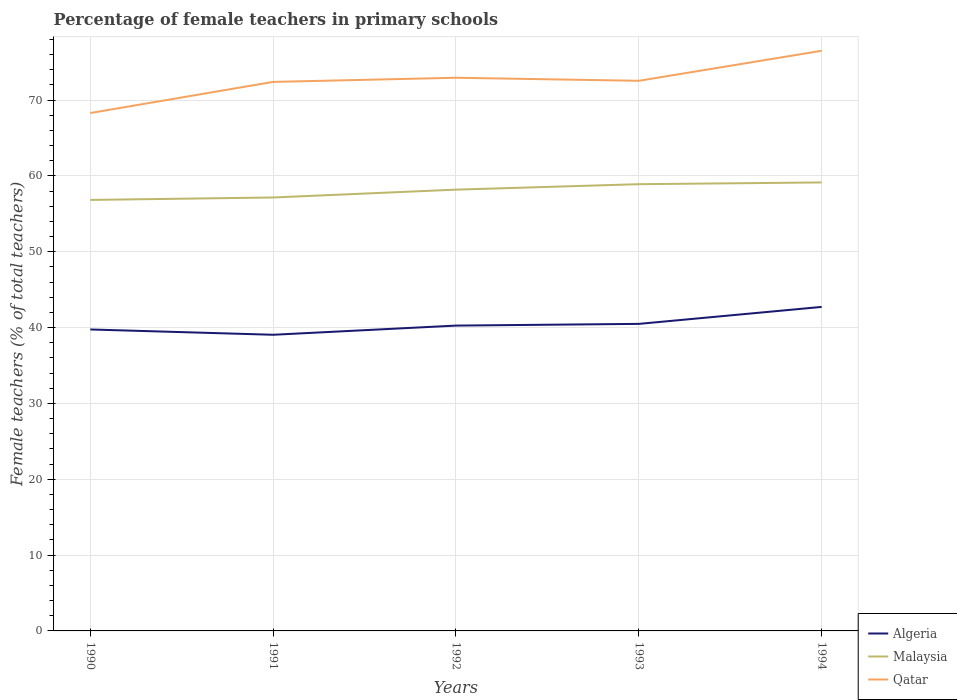Is the number of lines equal to the number of legend labels?
Your answer should be very brief. Yes. Across all years, what is the maximum percentage of female teachers in Malaysia?
Ensure brevity in your answer.  56.84. What is the total percentage of female teachers in Qatar in the graph?
Offer a very short reply. -4.1. What is the difference between the highest and the second highest percentage of female teachers in Qatar?
Offer a very short reply. 8.21. What is the difference between the highest and the lowest percentage of female teachers in Malaysia?
Give a very brief answer. 3. How many lines are there?
Your answer should be very brief. 3. What is the difference between two consecutive major ticks on the Y-axis?
Make the answer very short. 10. Does the graph contain grids?
Keep it short and to the point. Yes. Where does the legend appear in the graph?
Ensure brevity in your answer.  Bottom right. What is the title of the graph?
Provide a short and direct response. Percentage of female teachers in primary schools. Does "Finland" appear as one of the legend labels in the graph?
Ensure brevity in your answer.  No. What is the label or title of the Y-axis?
Keep it short and to the point. Female teachers (% of total teachers). What is the Female teachers (% of total teachers) in Algeria in 1990?
Give a very brief answer. 39.75. What is the Female teachers (% of total teachers) of Malaysia in 1990?
Your answer should be compact. 56.84. What is the Female teachers (% of total teachers) of Qatar in 1990?
Offer a terse response. 68.29. What is the Female teachers (% of total teachers) in Algeria in 1991?
Your answer should be very brief. 39.05. What is the Female teachers (% of total teachers) in Malaysia in 1991?
Give a very brief answer. 57.16. What is the Female teachers (% of total teachers) in Qatar in 1991?
Make the answer very short. 72.4. What is the Female teachers (% of total teachers) in Algeria in 1992?
Give a very brief answer. 40.26. What is the Female teachers (% of total teachers) in Malaysia in 1992?
Offer a terse response. 58.19. What is the Female teachers (% of total teachers) of Qatar in 1992?
Give a very brief answer. 72.94. What is the Female teachers (% of total teachers) of Algeria in 1993?
Provide a short and direct response. 40.49. What is the Female teachers (% of total teachers) in Malaysia in 1993?
Ensure brevity in your answer.  58.91. What is the Female teachers (% of total teachers) in Qatar in 1993?
Offer a terse response. 72.54. What is the Female teachers (% of total teachers) in Algeria in 1994?
Provide a succinct answer. 42.73. What is the Female teachers (% of total teachers) of Malaysia in 1994?
Make the answer very short. 59.14. What is the Female teachers (% of total teachers) of Qatar in 1994?
Your response must be concise. 76.5. Across all years, what is the maximum Female teachers (% of total teachers) of Algeria?
Your answer should be compact. 42.73. Across all years, what is the maximum Female teachers (% of total teachers) of Malaysia?
Your response must be concise. 59.14. Across all years, what is the maximum Female teachers (% of total teachers) of Qatar?
Your answer should be compact. 76.5. Across all years, what is the minimum Female teachers (% of total teachers) of Algeria?
Ensure brevity in your answer.  39.05. Across all years, what is the minimum Female teachers (% of total teachers) in Malaysia?
Offer a very short reply. 56.84. Across all years, what is the minimum Female teachers (% of total teachers) in Qatar?
Offer a terse response. 68.29. What is the total Female teachers (% of total teachers) in Algeria in the graph?
Your answer should be compact. 202.28. What is the total Female teachers (% of total teachers) of Malaysia in the graph?
Provide a short and direct response. 290.23. What is the total Female teachers (% of total teachers) in Qatar in the graph?
Offer a very short reply. 362.68. What is the difference between the Female teachers (% of total teachers) of Algeria in 1990 and that in 1991?
Provide a short and direct response. 0.7. What is the difference between the Female teachers (% of total teachers) in Malaysia in 1990 and that in 1991?
Your answer should be very brief. -0.32. What is the difference between the Female teachers (% of total teachers) of Qatar in 1990 and that in 1991?
Your answer should be compact. -4.11. What is the difference between the Female teachers (% of total teachers) of Algeria in 1990 and that in 1992?
Make the answer very short. -0.51. What is the difference between the Female teachers (% of total teachers) of Malaysia in 1990 and that in 1992?
Make the answer very short. -1.35. What is the difference between the Female teachers (% of total teachers) in Qatar in 1990 and that in 1992?
Offer a very short reply. -4.65. What is the difference between the Female teachers (% of total teachers) of Algeria in 1990 and that in 1993?
Offer a very short reply. -0.74. What is the difference between the Female teachers (% of total teachers) of Malaysia in 1990 and that in 1993?
Give a very brief answer. -2.07. What is the difference between the Female teachers (% of total teachers) of Qatar in 1990 and that in 1993?
Ensure brevity in your answer.  -4.25. What is the difference between the Female teachers (% of total teachers) in Algeria in 1990 and that in 1994?
Keep it short and to the point. -2.98. What is the difference between the Female teachers (% of total teachers) in Malaysia in 1990 and that in 1994?
Offer a terse response. -2.3. What is the difference between the Female teachers (% of total teachers) in Qatar in 1990 and that in 1994?
Your answer should be very brief. -8.21. What is the difference between the Female teachers (% of total teachers) in Algeria in 1991 and that in 1992?
Make the answer very short. -1.21. What is the difference between the Female teachers (% of total teachers) in Malaysia in 1991 and that in 1992?
Offer a very short reply. -1.03. What is the difference between the Female teachers (% of total teachers) in Qatar in 1991 and that in 1992?
Provide a short and direct response. -0.55. What is the difference between the Female teachers (% of total teachers) in Algeria in 1991 and that in 1993?
Ensure brevity in your answer.  -1.43. What is the difference between the Female teachers (% of total teachers) in Malaysia in 1991 and that in 1993?
Give a very brief answer. -1.75. What is the difference between the Female teachers (% of total teachers) of Qatar in 1991 and that in 1993?
Keep it short and to the point. -0.15. What is the difference between the Female teachers (% of total teachers) in Algeria in 1991 and that in 1994?
Ensure brevity in your answer.  -3.67. What is the difference between the Female teachers (% of total teachers) in Malaysia in 1991 and that in 1994?
Your response must be concise. -1.98. What is the difference between the Female teachers (% of total teachers) in Qatar in 1991 and that in 1994?
Give a very brief answer. -4.1. What is the difference between the Female teachers (% of total teachers) of Algeria in 1992 and that in 1993?
Ensure brevity in your answer.  -0.23. What is the difference between the Female teachers (% of total teachers) in Malaysia in 1992 and that in 1993?
Provide a succinct answer. -0.72. What is the difference between the Female teachers (% of total teachers) of Qatar in 1992 and that in 1993?
Offer a very short reply. 0.4. What is the difference between the Female teachers (% of total teachers) of Algeria in 1992 and that in 1994?
Ensure brevity in your answer.  -2.46. What is the difference between the Female teachers (% of total teachers) in Malaysia in 1992 and that in 1994?
Provide a succinct answer. -0.95. What is the difference between the Female teachers (% of total teachers) in Qatar in 1992 and that in 1994?
Ensure brevity in your answer.  -3.56. What is the difference between the Female teachers (% of total teachers) in Algeria in 1993 and that in 1994?
Offer a very short reply. -2.24. What is the difference between the Female teachers (% of total teachers) in Malaysia in 1993 and that in 1994?
Offer a very short reply. -0.23. What is the difference between the Female teachers (% of total teachers) of Qatar in 1993 and that in 1994?
Provide a short and direct response. -3.96. What is the difference between the Female teachers (% of total teachers) of Algeria in 1990 and the Female teachers (% of total teachers) of Malaysia in 1991?
Give a very brief answer. -17.41. What is the difference between the Female teachers (% of total teachers) of Algeria in 1990 and the Female teachers (% of total teachers) of Qatar in 1991?
Ensure brevity in your answer.  -32.65. What is the difference between the Female teachers (% of total teachers) in Malaysia in 1990 and the Female teachers (% of total teachers) in Qatar in 1991?
Provide a short and direct response. -15.56. What is the difference between the Female teachers (% of total teachers) of Algeria in 1990 and the Female teachers (% of total teachers) of Malaysia in 1992?
Offer a very short reply. -18.44. What is the difference between the Female teachers (% of total teachers) in Algeria in 1990 and the Female teachers (% of total teachers) in Qatar in 1992?
Offer a terse response. -33.19. What is the difference between the Female teachers (% of total teachers) in Malaysia in 1990 and the Female teachers (% of total teachers) in Qatar in 1992?
Your answer should be compact. -16.11. What is the difference between the Female teachers (% of total teachers) in Algeria in 1990 and the Female teachers (% of total teachers) in Malaysia in 1993?
Give a very brief answer. -19.16. What is the difference between the Female teachers (% of total teachers) in Algeria in 1990 and the Female teachers (% of total teachers) in Qatar in 1993?
Your answer should be compact. -32.79. What is the difference between the Female teachers (% of total teachers) in Malaysia in 1990 and the Female teachers (% of total teachers) in Qatar in 1993?
Provide a short and direct response. -15.71. What is the difference between the Female teachers (% of total teachers) in Algeria in 1990 and the Female teachers (% of total teachers) in Malaysia in 1994?
Your answer should be very brief. -19.39. What is the difference between the Female teachers (% of total teachers) of Algeria in 1990 and the Female teachers (% of total teachers) of Qatar in 1994?
Offer a terse response. -36.75. What is the difference between the Female teachers (% of total teachers) in Malaysia in 1990 and the Female teachers (% of total teachers) in Qatar in 1994?
Ensure brevity in your answer.  -19.67. What is the difference between the Female teachers (% of total teachers) in Algeria in 1991 and the Female teachers (% of total teachers) in Malaysia in 1992?
Your answer should be compact. -19.14. What is the difference between the Female teachers (% of total teachers) of Algeria in 1991 and the Female teachers (% of total teachers) of Qatar in 1992?
Provide a short and direct response. -33.89. What is the difference between the Female teachers (% of total teachers) of Malaysia in 1991 and the Female teachers (% of total teachers) of Qatar in 1992?
Offer a terse response. -15.79. What is the difference between the Female teachers (% of total teachers) in Algeria in 1991 and the Female teachers (% of total teachers) in Malaysia in 1993?
Give a very brief answer. -19.86. What is the difference between the Female teachers (% of total teachers) in Algeria in 1991 and the Female teachers (% of total teachers) in Qatar in 1993?
Provide a short and direct response. -33.49. What is the difference between the Female teachers (% of total teachers) of Malaysia in 1991 and the Female teachers (% of total teachers) of Qatar in 1993?
Offer a terse response. -15.39. What is the difference between the Female teachers (% of total teachers) in Algeria in 1991 and the Female teachers (% of total teachers) in Malaysia in 1994?
Make the answer very short. -20.09. What is the difference between the Female teachers (% of total teachers) in Algeria in 1991 and the Female teachers (% of total teachers) in Qatar in 1994?
Provide a short and direct response. -37.45. What is the difference between the Female teachers (% of total teachers) of Malaysia in 1991 and the Female teachers (% of total teachers) of Qatar in 1994?
Offer a very short reply. -19.35. What is the difference between the Female teachers (% of total teachers) in Algeria in 1992 and the Female teachers (% of total teachers) in Malaysia in 1993?
Provide a succinct answer. -18.65. What is the difference between the Female teachers (% of total teachers) in Algeria in 1992 and the Female teachers (% of total teachers) in Qatar in 1993?
Provide a succinct answer. -32.28. What is the difference between the Female teachers (% of total teachers) of Malaysia in 1992 and the Female teachers (% of total teachers) of Qatar in 1993?
Keep it short and to the point. -14.35. What is the difference between the Female teachers (% of total teachers) of Algeria in 1992 and the Female teachers (% of total teachers) of Malaysia in 1994?
Offer a very short reply. -18.88. What is the difference between the Female teachers (% of total teachers) of Algeria in 1992 and the Female teachers (% of total teachers) of Qatar in 1994?
Your response must be concise. -36.24. What is the difference between the Female teachers (% of total teachers) of Malaysia in 1992 and the Female teachers (% of total teachers) of Qatar in 1994?
Make the answer very short. -18.31. What is the difference between the Female teachers (% of total teachers) of Algeria in 1993 and the Female teachers (% of total teachers) of Malaysia in 1994?
Your response must be concise. -18.65. What is the difference between the Female teachers (% of total teachers) of Algeria in 1993 and the Female teachers (% of total teachers) of Qatar in 1994?
Offer a terse response. -36.01. What is the difference between the Female teachers (% of total teachers) of Malaysia in 1993 and the Female teachers (% of total teachers) of Qatar in 1994?
Keep it short and to the point. -17.59. What is the average Female teachers (% of total teachers) in Algeria per year?
Your answer should be very brief. 40.46. What is the average Female teachers (% of total teachers) of Malaysia per year?
Ensure brevity in your answer.  58.05. What is the average Female teachers (% of total teachers) in Qatar per year?
Your response must be concise. 72.54. In the year 1990, what is the difference between the Female teachers (% of total teachers) in Algeria and Female teachers (% of total teachers) in Malaysia?
Make the answer very short. -17.08. In the year 1990, what is the difference between the Female teachers (% of total teachers) of Algeria and Female teachers (% of total teachers) of Qatar?
Your answer should be compact. -28.54. In the year 1990, what is the difference between the Female teachers (% of total teachers) in Malaysia and Female teachers (% of total teachers) in Qatar?
Make the answer very short. -11.46. In the year 1991, what is the difference between the Female teachers (% of total teachers) of Algeria and Female teachers (% of total teachers) of Malaysia?
Ensure brevity in your answer.  -18.1. In the year 1991, what is the difference between the Female teachers (% of total teachers) of Algeria and Female teachers (% of total teachers) of Qatar?
Keep it short and to the point. -33.34. In the year 1991, what is the difference between the Female teachers (% of total teachers) in Malaysia and Female teachers (% of total teachers) in Qatar?
Provide a succinct answer. -15.24. In the year 1992, what is the difference between the Female teachers (% of total teachers) in Algeria and Female teachers (% of total teachers) in Malaysia?
Your answer should be compact. -17.93. In the year 1992, what is the difference between the Female teachers (% of total teachers) of Algeria and Female teachers (% of total teachers) of Qatar?
Provide a short and direct response. -32.68. In the year 1992, what is the difference between the Female teachers (% of total teachers) in Malaysia and Female teachers (% of total teachers) in Qatar?
Make the answer very short. -14.75. In the year 1993, what is the difference between the Female teachers (% of total teachers) in Algeria and Female teachers (% of total teachers) in Malaysia?
Offer a terse response. -18.42. In the year 1993, what is the difference between the Female teachers (% of total teachers) of Algeria and Female teachers (% of total teachers) of Qatar?
Your answer should be compact. -32.06. In the year 1993, what is the difference between the Female teachers (% of total teachers) in Malaysia and Female teachers (% of total teachers) in Qatar?
Your response must be concise. -13.63. In the year 1994, what is the difference between the Female teachers (% of total teachers) of Algeria and Female teachers (% of total teachers) of Malaysia?
Your response must be concise. -16.41. In the year 1994, what is the difference between the Female teachers (% of total teachers) of Algeria and Female teachers (% of total teachers) of Qatar?
Offer a terse response. -33.78. In the year 1994, what is the difference between the Female teachers (% of total teachers) in Malaysia and Female teachers (% of total teachers) in Qatar?
Give a very brief answer. -17.36. What is the ratio of the Female teachers (% of total teachers) in Algeria in 1990 to that in 1991?
Your response must be concise. 1.02. What is the ratio of the Female teachers (% of total teachers) in Qatar in 1990 to that in 1991?
Your answer should be compact. 0.94. What is the ratio of the Female teachers (% of total teachers) of Algeria in 1990 to that in 1992?
Keep it short and to the point. 0.99. What is the ratio of the Female teachers (% of total teachers) in Malaysia in 1990 to that in 1992?
Provide a succinct answer. 0.98. What is the ratio of the Female teachers (% of total teachers) of Qatar in 1990 to that in 1992?
Provide a short and direct response. 0.94. What is the ratio of the Female teachers (% of total teachers) in Algeria in 1990 to that in 1993?
Offer a very short reply. 0.98. What is the ratio of the Female teachers (% of total teachers) in Malaysia in 1990 to that in 1993?
Ensure brevity in your answer.  0.96. What is the ratio of the Female teachers (% of total teachers) of Qatar in 1990 to that in 1993?
Keep it short and to the point. 0.94. What is the ratio of the Female teachers (% of total teachers) in Algeria in 1990 to that in 1994?
Provide a short and direct response. 0.93. What is the ratio of the Female teachers (% of total teachers) of Qatar in 1990 to that in 1994?
Your response must be concise. 0.89. What is the ratio of the Female teachers (% of total teachers) in Algeria in 1991 to that in 1992?
Keep it short and to the point. 0.97. What is the ratio of the Female teachers (% of total teachers) in Malaysia in 1991 to that in 1992?
Offer a very short reply. 0.98. What is the ratio of the Female teachers (% of total teachers) of Qatar in 1991 to that in 1992?
Your answer should be compact. 0.99. What is the ratio of the Female teachers (% of total teachers) in Algeria in 1991 to that in 1993?
Your response must be concise. 0.96. What is the ratio of the Female teachers (% of total teachers) of Malaysia in 1991 to that in 1993?
Provide a succinct answer. 0.97. What is the ratio of the Female teachers (% of total teachers) of Qatar in 1991 to that in 1993?
Provide a short and direct response. 1. What is the ratio of the Female teachers (% of total teachers) in Algeria in 1991 to that in 1994?
Make the answer very short. 0.91. What is the ratio of the Female teachers (% of total teachers) in Malaysia in 1991 to that in 1994?
Provide a short and direct response. 0.97. What is the ratio of the Female teachers (% of total teachers) in Qatar in 1991 to that in 1994?
Make the answer very short. 0.95. What is the ratio of the Female teachers (% of total teachers) of Algeria in 1992 to that in 1993?
Keep it short and to the point. 0.99. What is the ratio of the Female teachers (% of total teachers) in Malaysia in 1992 to that in 1993?
Offer a very short reply. 0.99. What is the ratio of the Female teachers (% of total teachers) in Algeria in 1992 to that in 1994?
Provide a short and direct response. 0.94. What is the ratio of the Female teachers (% of total teachers) of Malaysia in 1992 to that in 1994?
Provide a short and direct response. 0.98. What is the ratio of the Female teachers (% of total teachers) in Qatar in 1992 to that in 1994?
Offer a very short reply. 0.95. What is the ratio of the Female teachers (% of total teachers) of Algeria in 1993 to that in 1994?
Your answer should be compact. 0.95. What is the ratio of the Female teachers (% of total teachers) of Malaysia in 1993 to that in 1994?
Provide a succinct answer. 1. What is the ratio of the Female teachers (% of total teachers) of Qatar in 1993 to that in 1994?
Ensure brevity in your answer.  0.95. What is the difference between the highest and the second highest Female teachers (% of total teachers) of Algeria?
Provide a succinct answer. 2.24. What is the difference between the highest and the second highest Female teachers (% of total teachers) in Malaysia?
Make the answer very short. 0.23. What is the difference between the highest and the second highest Female teachers (% of total teachers) of Qatar?
Keep it short and to the point. 3.56. What is the difference between the highest and the lowest Female teachers (% of total teachers) in Algeria?
Keep it short and to the point. 3.67. What is the difference between the highest and the lowest Female teachers (% of total teachers) of Malaysia?
Give a very brief answer. 2.3. What is the difference between the highest and the lowest Female teachers (% of total teachers) in Qatar?
Provide a short and direct response. 8.21. 